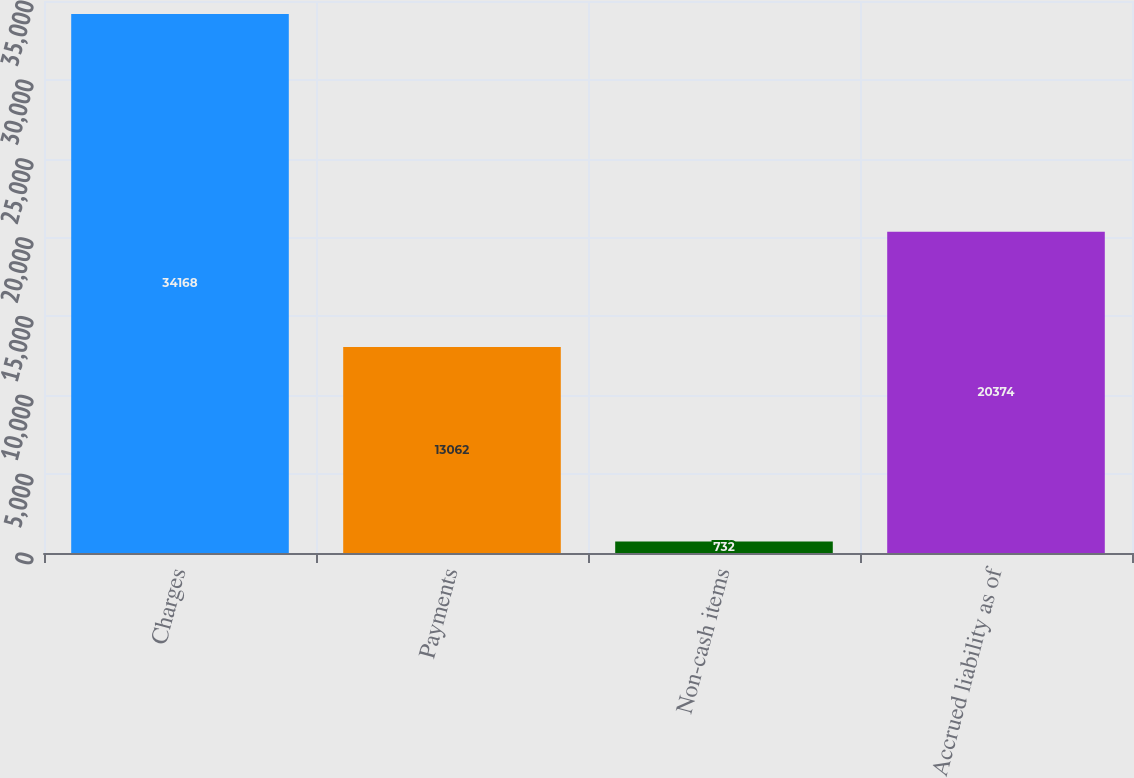<chart> <loc_0><loc_0><loc_500><loc_500><bar_chart><fcel>Charges<fcel>Payments<fcel>Non-cash items<fcel>Accrued liability as of<nl><fcel>34168<fcel>13062<fcel>732<fcel>20374<nl></chart> 